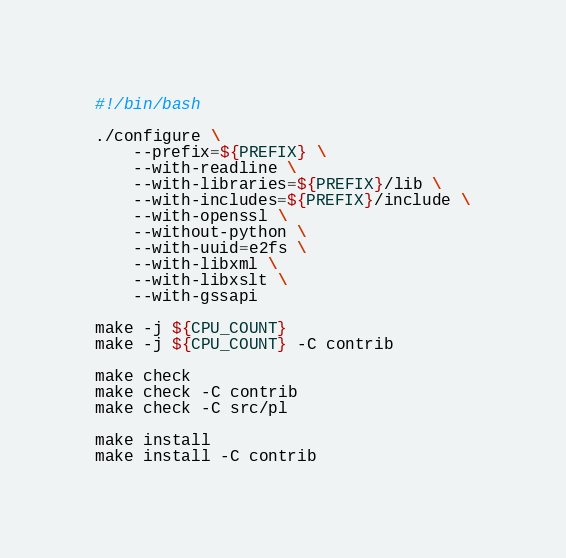Convert code to text. <code><loc_0><loc_0><loc_500><loc_500><_Bash_>#!/bin/bash

./configure \
    --prefix=${PREFIX} \
    --with-readline \
    --with-libraries=${PREFIX}/lib \
    --with-includes=${PREFIX}/include \
    --with-openssl \
    --without-python \
    --with-uuid=e2fs \
    --with-libxml \
    --with-libxslt \
    --with-gssapi

make -j ${CPU_COUNT}
make -j ${CPU_COUNT} -C contrib

make check
make check -C contrib
make check -C src/pl

make install
make install -C contrib
</code> 